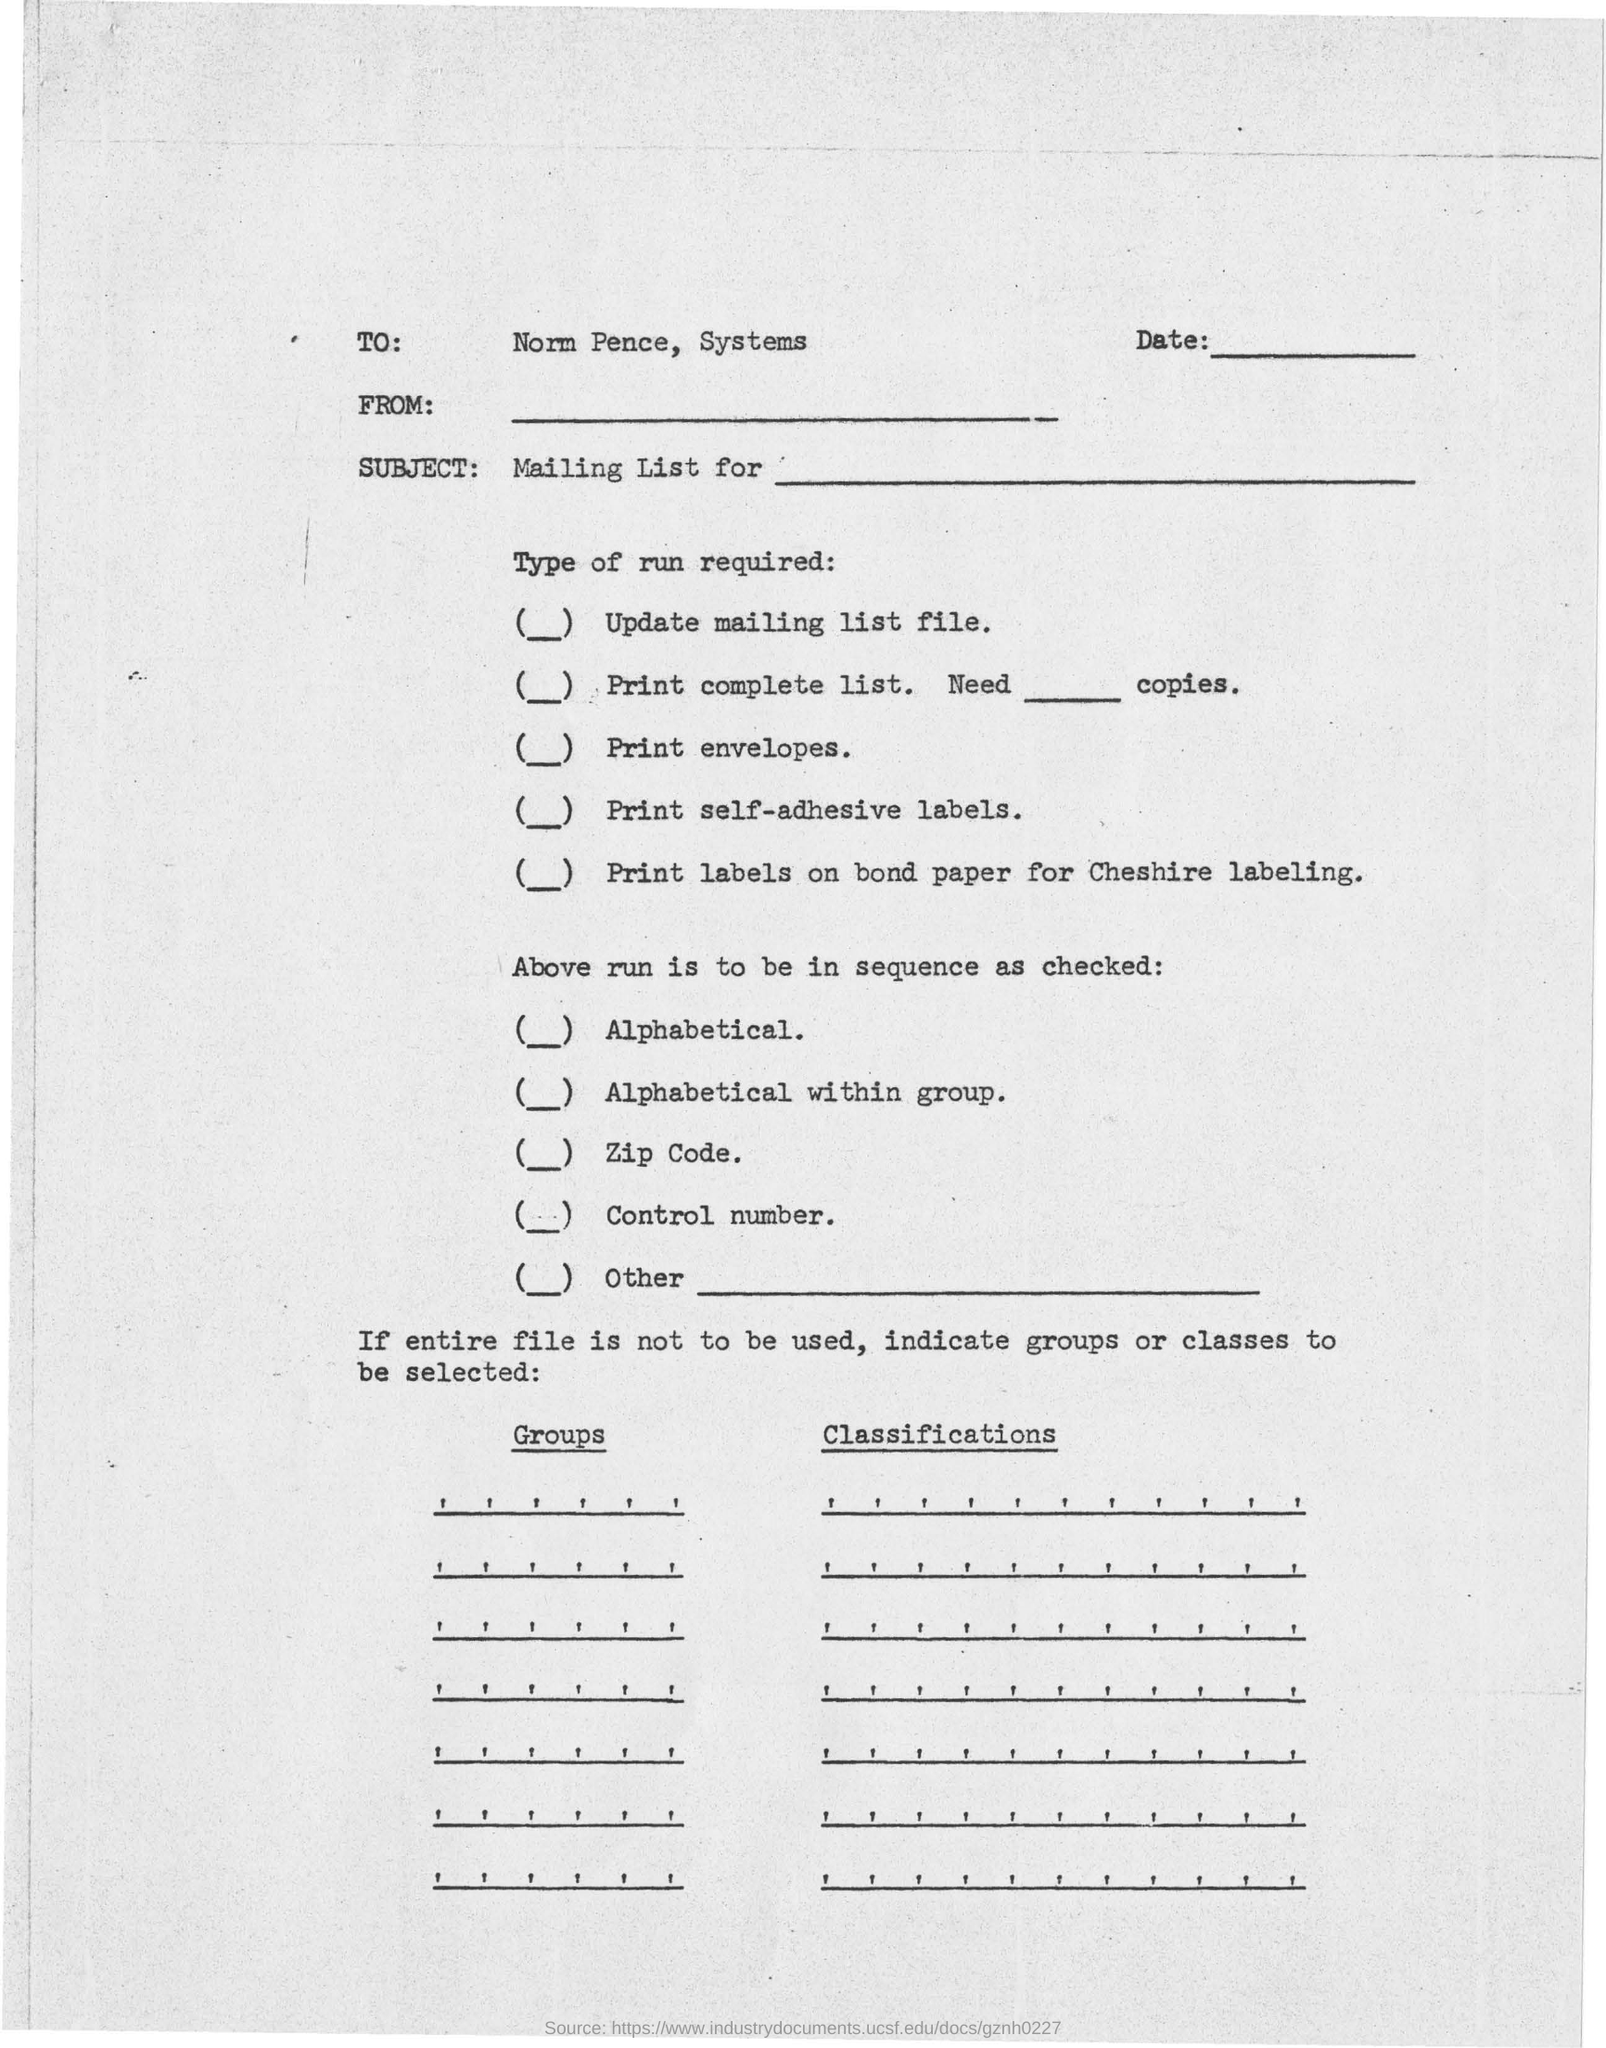Indicate a few pertinent items in this graphic. The TO mentioned is Norm Pence. 